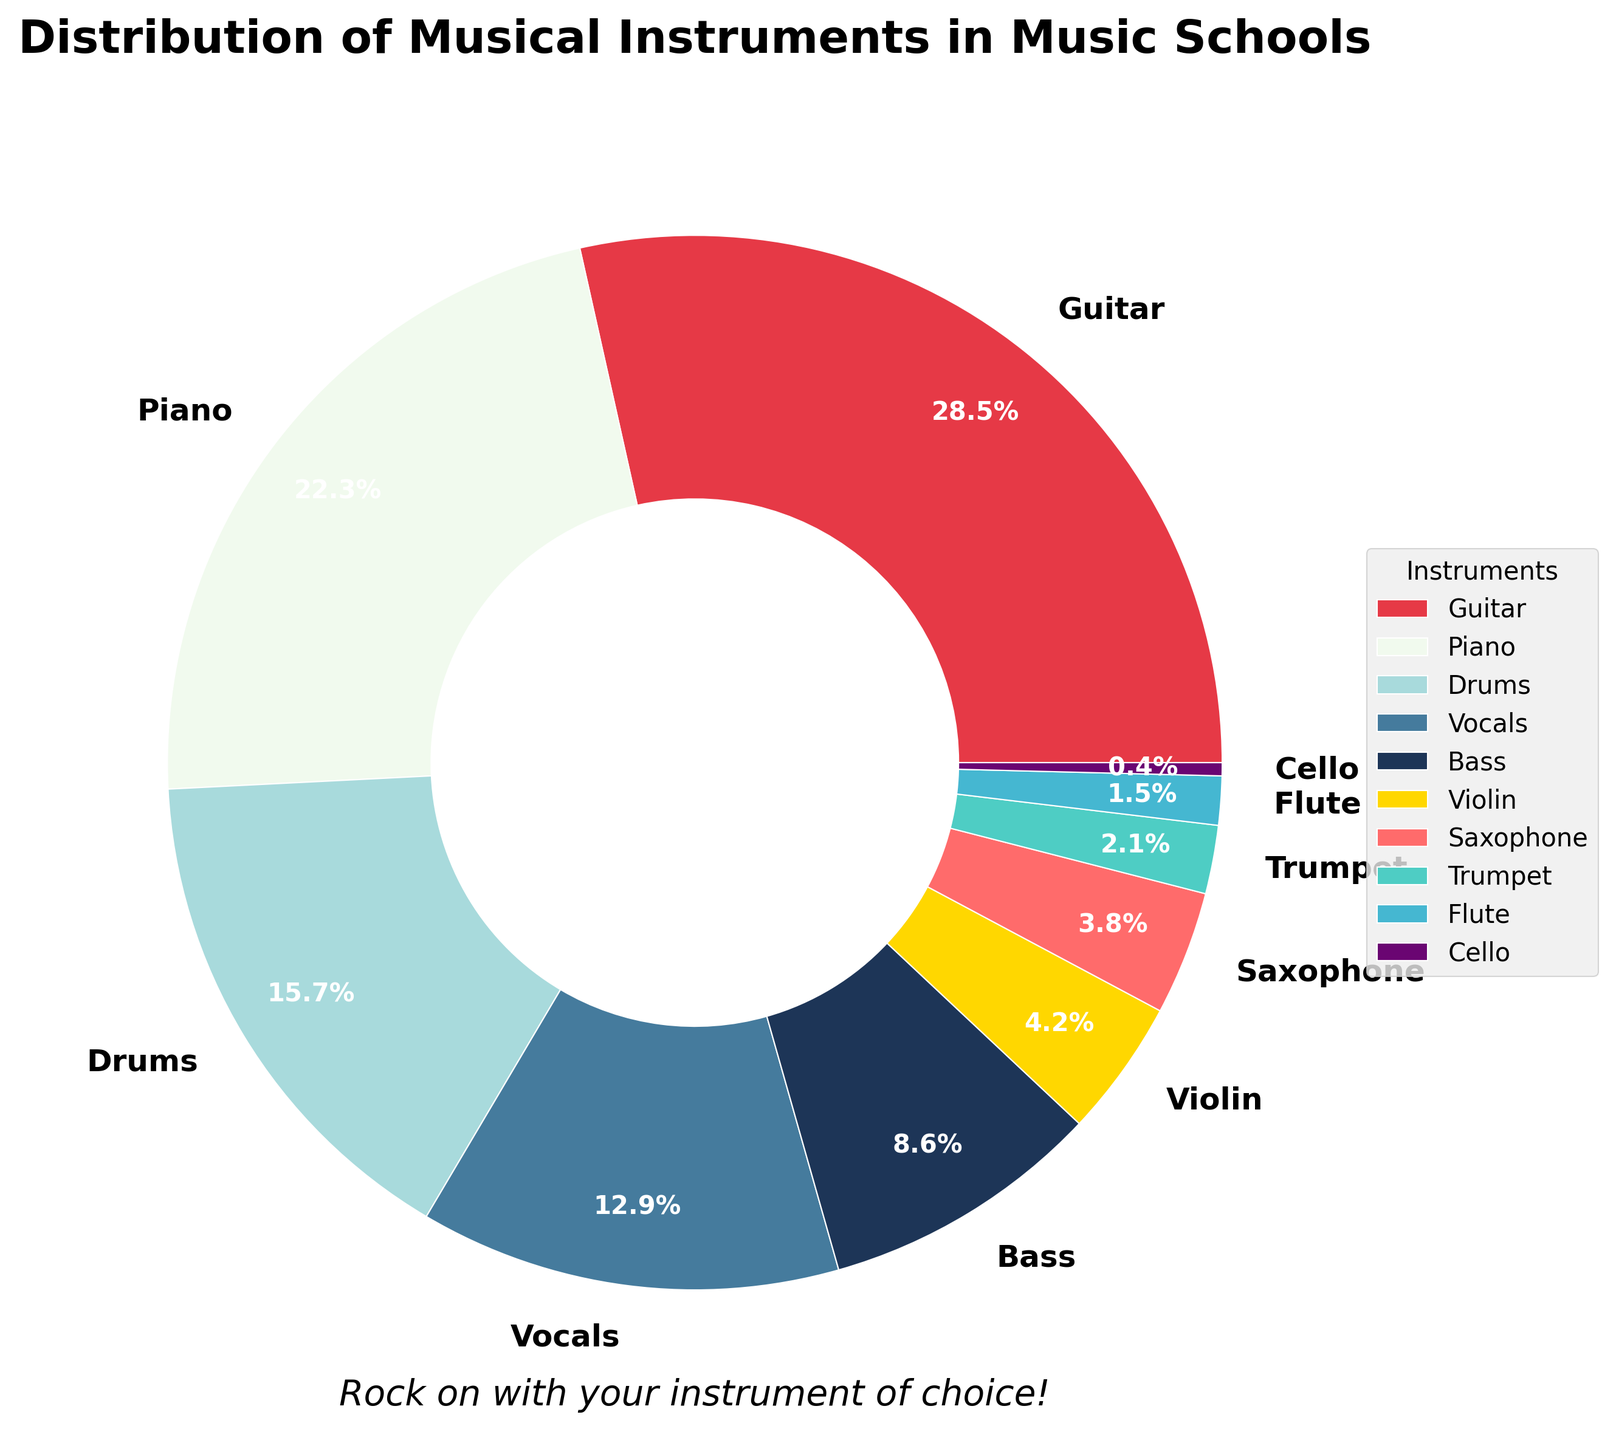Which instrument has the highest percentage of students pursuing it? The pie chart shows the distribution of various instruments, and the segment labeled 'Guitar' has the largest portion. Therefore, the Guitar has the highest percentage.
Answer: Guitar Which instrument has the smallest percentage of students pursuing it? The pie chart shows the smallest segment is labeled 'Cello', indicating that Cello has the smallest percentage of students.
Answer: Cello How many instruments have a percentage greater than 20%? From the pie chart, only the Guitar (28.5%) and Piano (22.3%) segments exceed 20%. Counting these yields 2 instruments.
Answer: 2 What's the total percentage of students pursuing Vocals and Drums combined? Summing up the segments for Vocals (12.9%) and Drums (15.7%) gives the total percentage as 12.9 + 15.7 = 28.6%.
Answer: 28.6% Which is more popular, Violin or Bass? Comparing the percentage segments for Bass (8.6%) and Violin (4.2%), it is evident that Bass has a higher percentage.
Answer: Bass Describe the color of the segment representing Piano. The segment labeled Piano is shown in a white color.
Answer: White How does the percentage of students pursuing Saxophone compare to Trumpet? The pie chart shows that the percentage for Saxophone (3.8%) is greater than for Trumpet (2.1%).
Answer: Saxophone has a higher percentage What's the average percentage of students pursuing Guitar and Piano? To find the average, sum the percentages of Guitar (28.5%) and Piano (22.3%) and divide by 2. (28.5 + 22.3) / 2 = 25.4%.
Answer: 25.4% Arrange the instruments in descending order based on the percentage of students pursuing them. Sort all instruments by their segments in descending order: Guitar (28.5%), Piano (22.3%), Drums (15.7%), Vocals (12.9%), Bass (8.6%), Violin (4.2%), Saxophone (3.8%), Trumpet (2.1%), Flute (1.5%), Cello (0.4%).
Answer: Guitar, Piano, Drums, Vocals, Bass, Violin, Saxophone, Trumpet, Flute, Cello What is the combined percentage for Flute, Cello, and Saxophone? The combined percentage is the sum of Flute (1.5%), Cello (0.4%), and Saxophone (3.8%). Adding these together: 1.5 + 0.4 + 3.8 = 5.7%.
Answer: 5.7% 